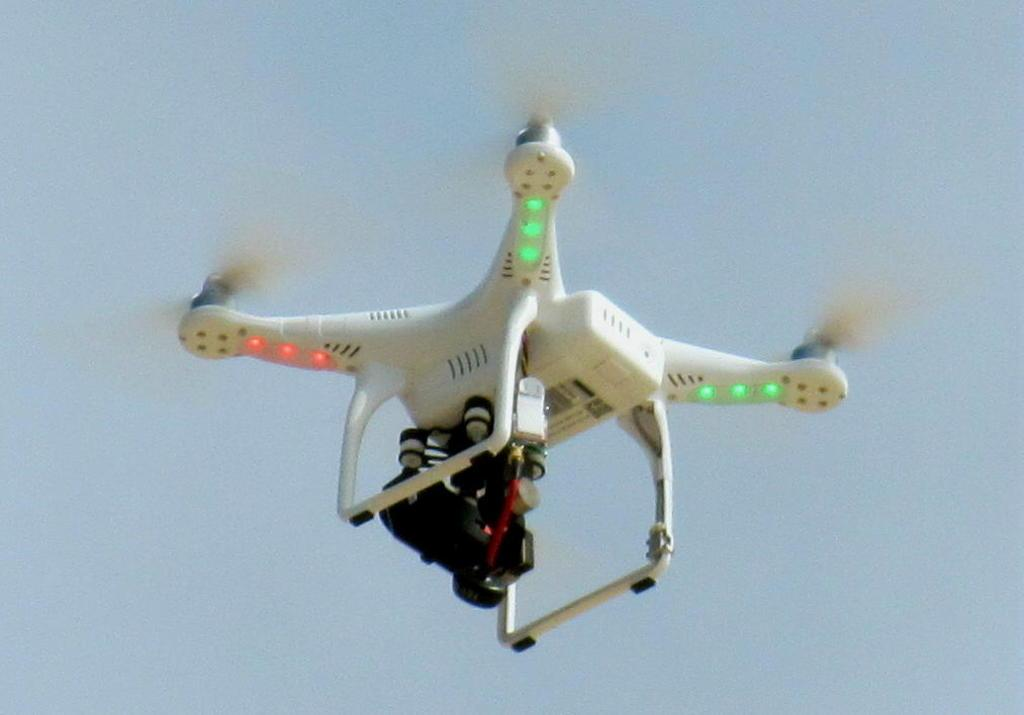What is the main subject of the image? The main subject of the image is a drone. Where is the drone located in the image? The drone is in the center of the image. What type of plantation can be seen in the background of the image? There is no plantation visible in the image; it only features a drone in the center. What is the weight of the drone in the image? The weight of the drone cannot be determined from the image alone. 